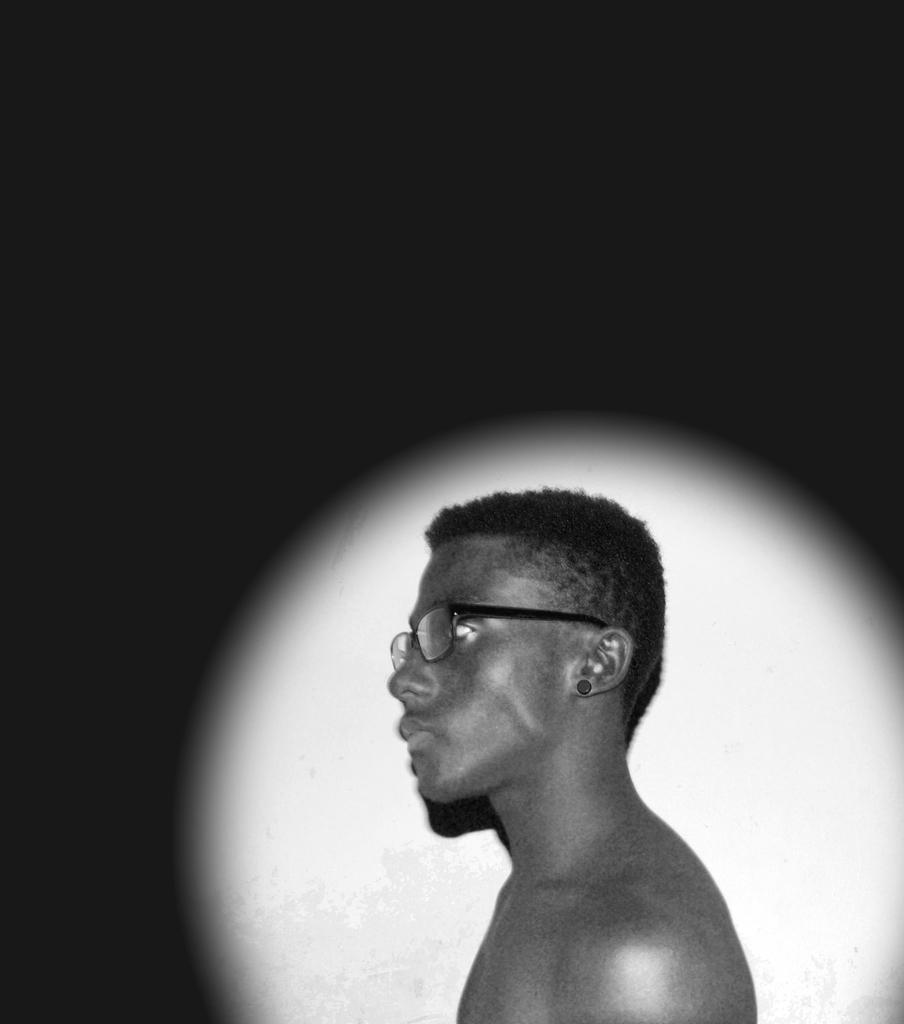What is the person in the image wearing on their upper body? The person in the image is not wearing a shirt. What accessory is the person wearing on their face? The person is wearing spectacles. What can be seen behind the person in the image? There is a white wall in the background of the image. How would you describe the overall color of the background in the image? The background of the image is dark in color. What type of leather material is covering the car in the image? There is no car present in the image, so there is no leather material to describe. 